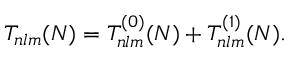Convert formula to latex. <formula><loc_0><loc_0><loc_500><loc_500>T _ { n l m } ( N ) = T _ { n l m } ^ { ( 0 ) } ( N ) + T _ { n l m } ^ { ( 1 ) } ( N ) .</formula> 